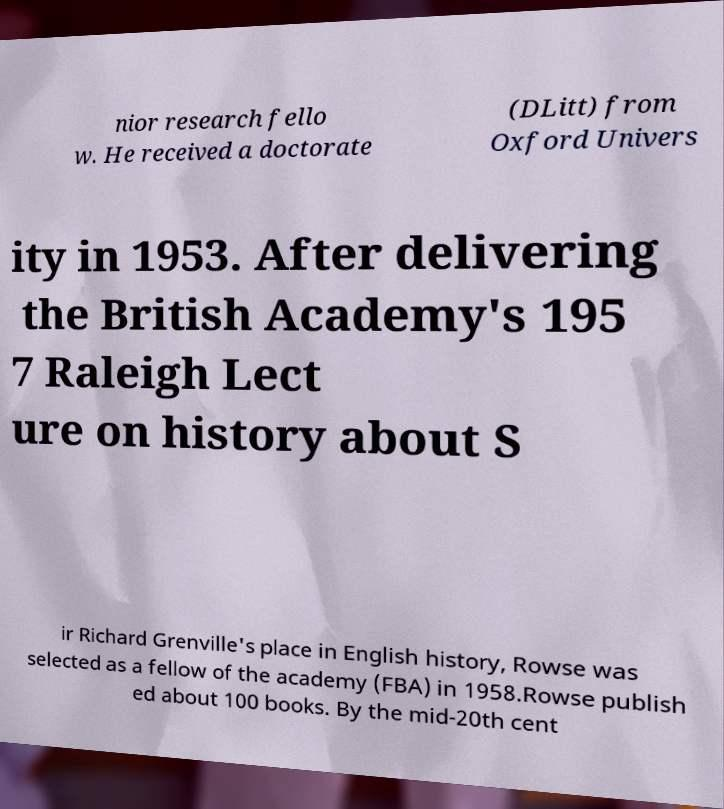For documentation purposes, I need the text within this image transcribed. Could you provide that? nior research fello w. He received a doctorate (DLitt) from Oxford Univers ity in 1953. After delivering the British Academy's 195 7 Raleigh Lect ure on history about S ir Richard Grenville's place in English history, Rowse was selected as a fellow of the academy (FBA) in 1958.Rowse publish ed about 100 books. By the mid-20th cent 